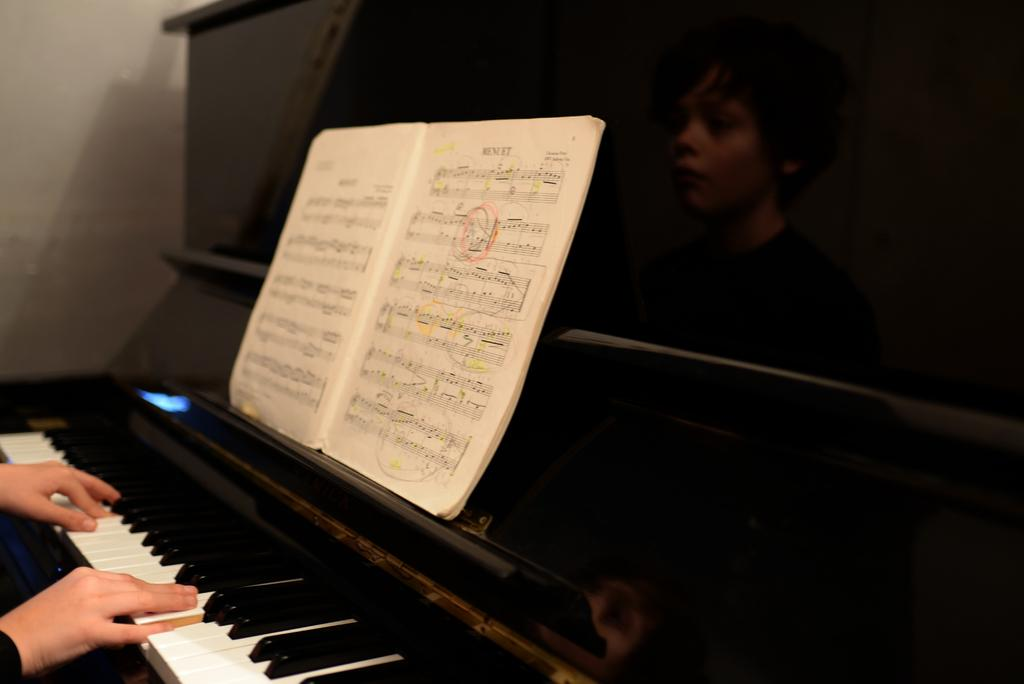Who is present in the image? There is a boy in the image. What object can be seen in the image related to learning or reading? There is a book in the image. What object in the image is related to music or sound production? There is a musical keyboard in the image. What type of cattle can be seen grazing in the background of the image? There is no cattle present in the image; it only features a boy, a book, and a musical keyboard. 